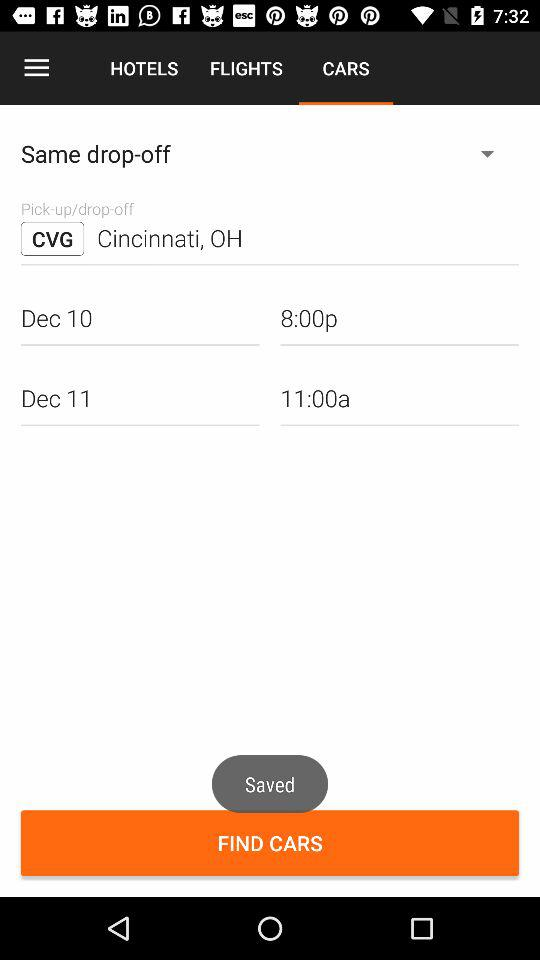What type of car will conduct the drop-off and pick-up?
When the provided information is insufficient, respond with <no answer>. <no answer> 